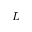Convert formula to latex. <formula><loc_0><loc_0><loc_500><loc_500>L</formula> 